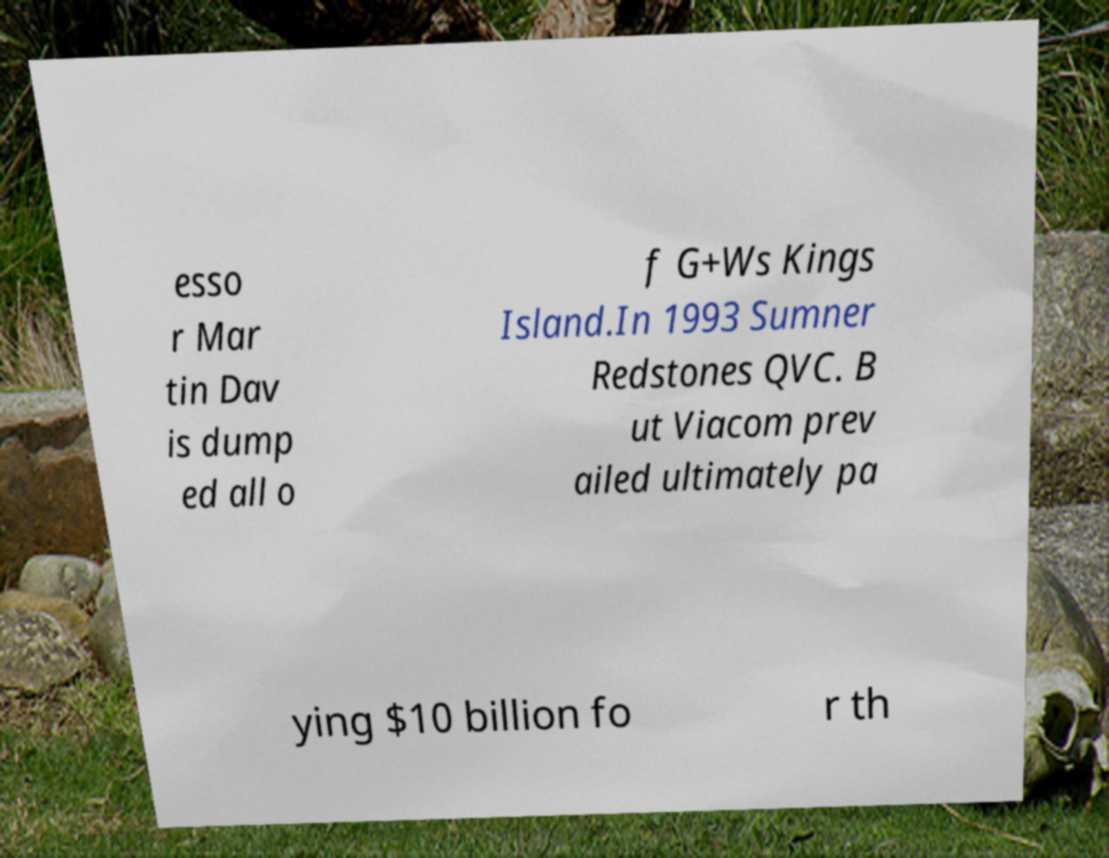I need the written content from this picture converted into text. Can you do that? esso r Mar tin Dav is dump ed all o f G+Ws Kings Island.In 1993 Sumner Redstones QVC. B ut Viacom prev ailed ultimately pa ying $10 billion fo r th 